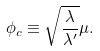Convert formula to latex. <formula><loc_0><loc_0><loc_500><loc_500>\phi _ { c } \equiv \sqrt { \frac { \lambda } { \lambda ^ { \prime } } } \mu .</formula> 